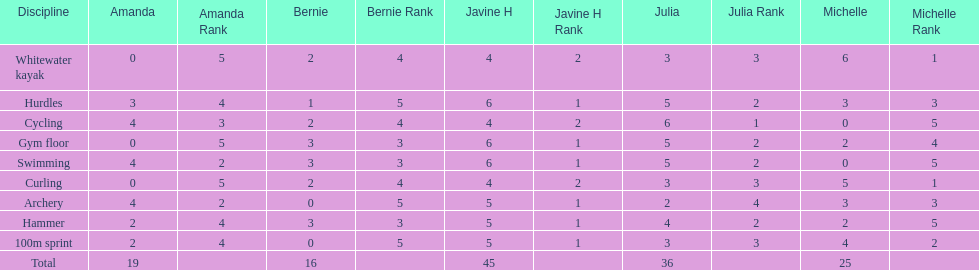Who is the faster runner? Javine H. 